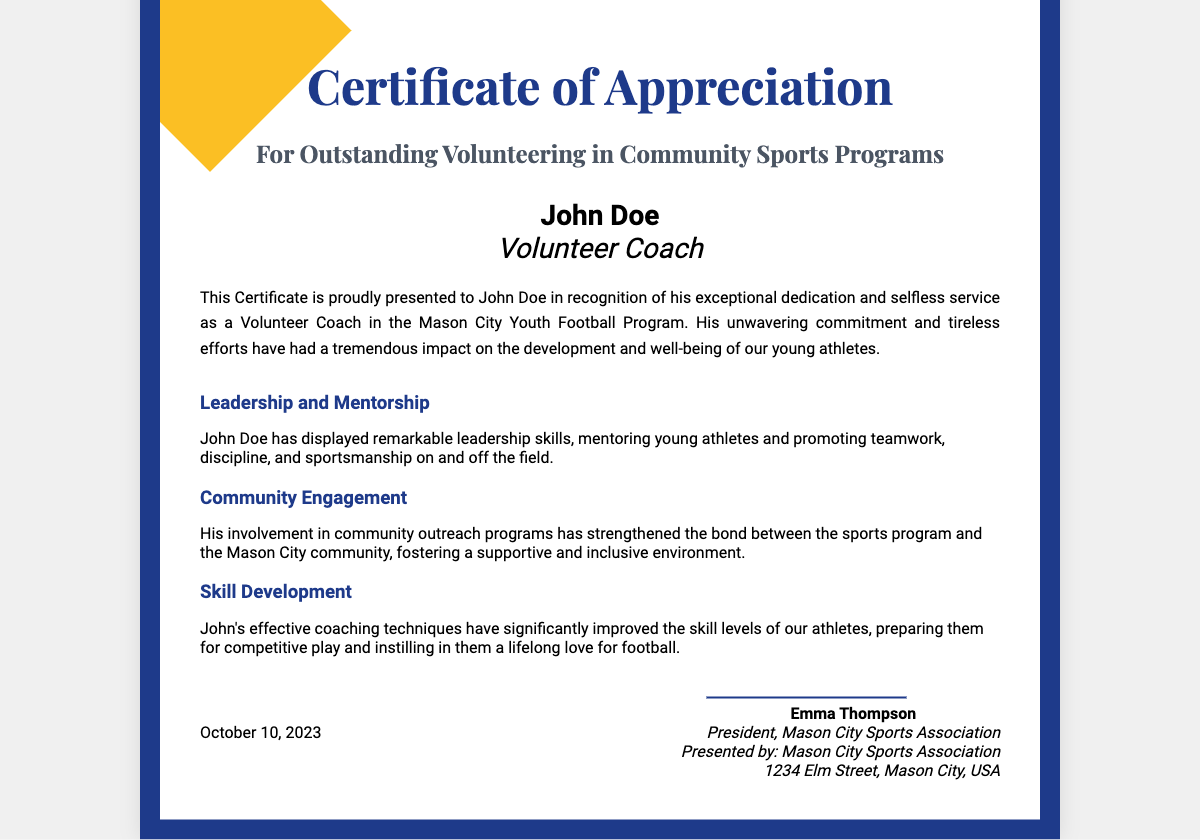What is the name of the recipient? The recipient's name is presented in the document as John Doe.
Answer: John Doe What is the title of the certificate? The title of the certificate is explicitly stated in the document as "Certificate of Appreciation".
Answer: Certificate of Appreciation What is the date on the certificate? The date mentioned in the document indicates when the certificate was issued, which is October 10, 2023.
Answer: October 10, 2023 Who is the presenter of the certificate? The presenter of the certificate is specified in the document as the Mason City Sports Association.
Answer: Mason City Sports Association What role did John Doe serve in the community program? The document describes John Doe's role as a Volunteer Coach.
Answer: Volunteer Coach What is one of John Doe's achievements? The document lists several achievements, including Leadership and Mentorship as one of them.
Answer: Leadership and Mentorship What does the certificate recognize? The certificate recognizes John Doe's exceptional dedication and selfless service.
Answer: Exceptional dedication and selfless service Who signed the certificate? The document shows that Emma Thompson signed the certificate as the President of the Mason City Sports Association.
Answer: Emma Thompson What is a key focus of John Doe's coaching? The document emphasizes that John Doe's coaching has improved athletes' skill levels.
Answer: Improved skill levels 